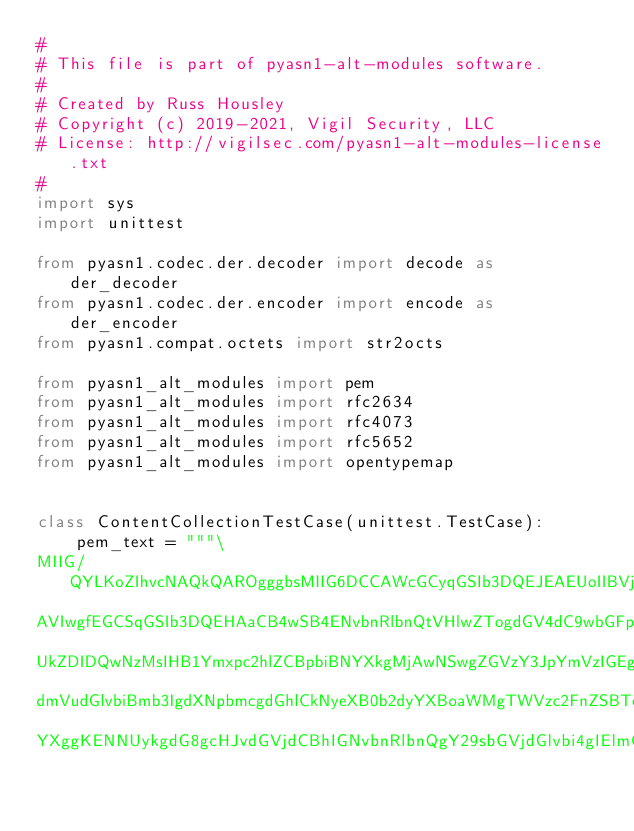Convert code to text. <code><loc_0><loc_0><loc_500><loc_500><_Python_>#
# This file is part of pyasn1-alt-modules software.
#
# Created by Russ Housley
# Copyright (c) 2019-2021, Vigil Security, LLC
# License: http://vigilsec.com/pyasn1-alt-modules-license.txt
#
import sys
import unittest

from pyasn1.codec.der.decoder import decode as der_decoder
from pyasn1.codec.der.encoder import encode as der_encoder
from pyasn1.compat.octets import str2octs

from pyasn1_alt_modules import pem
from pyasn1_alt_modules import rfc2634
from pyasn1_alt_modules import rfc4073
from pyasn1_alt_modules import rfc5652
from pyasn1_alt_modules import opentypemap


class ContentCollectionTestCase(unittest.TestCase):
    pem_text = """\
MIIG/QYLKoZIhvcNAQkQAROgggbsMIIG6DCCAWcGCyqGSIb3DQEJEAEUoIIBVjCC
AVIwgfEGCSqGSIb3DQEHAaCB4wSB4ENvbnRlbnQtVHlwZTogdGV4dC9wbGFpbgoK
UkZDIDQwNzMsIHB1Ymxpc2hlZCBpbiBNYXkgMjAwNSwgZGVzY3JpYmVzIGEgY29u
dmVudGlvbiBmb3IgdXNpbmcgdGhlCkNyeXB0b2dyYXBoaWMgTWVzc2FnZSBTeW50
YXggKENNUykgdG8gcHJvdGVjdCBhIGNvbnRlbnQgY29sbGVjdGlvbi4gIElmCmRl</code> 